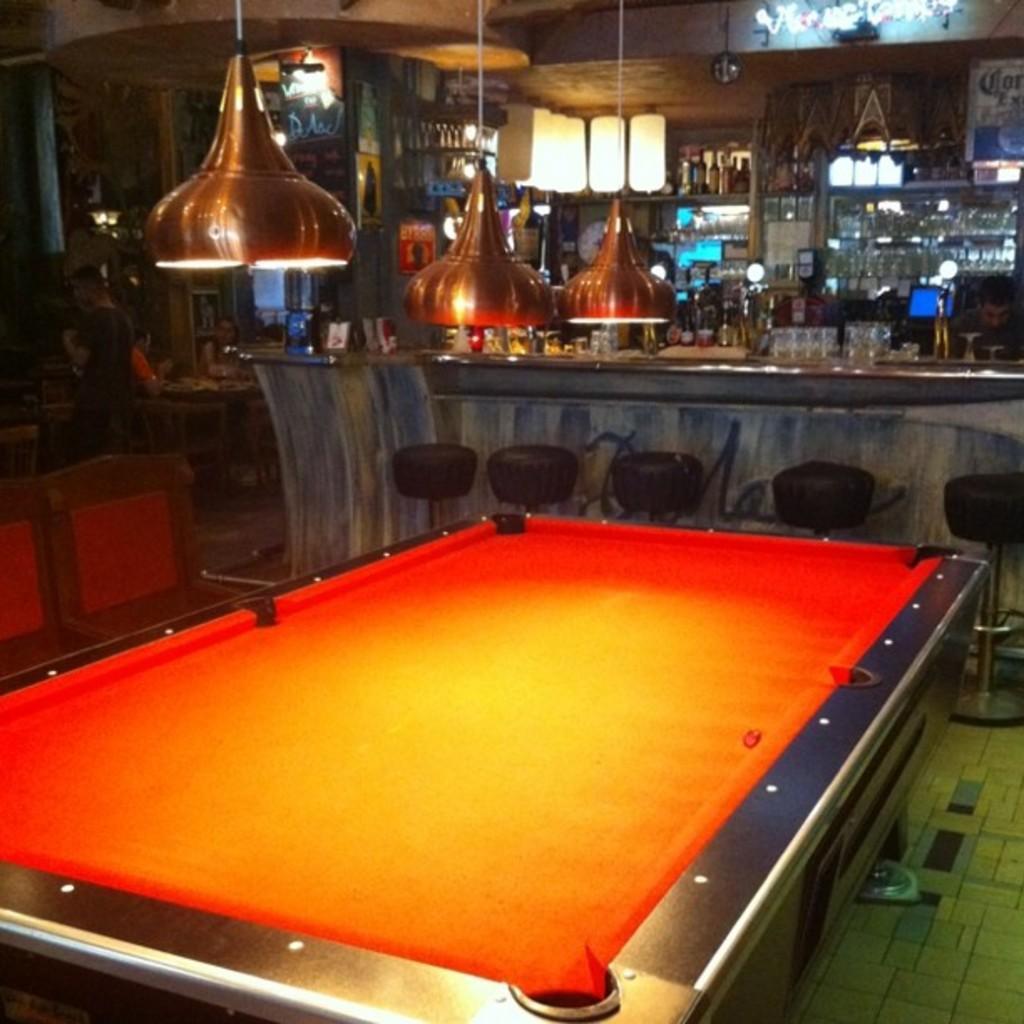Can you describe this image briefly? In this image there is a snooker table, at the top there are lights, in the background there are chairs and a desk, behind the desk there are shelves, in that shelves there are glasses and bottles. 